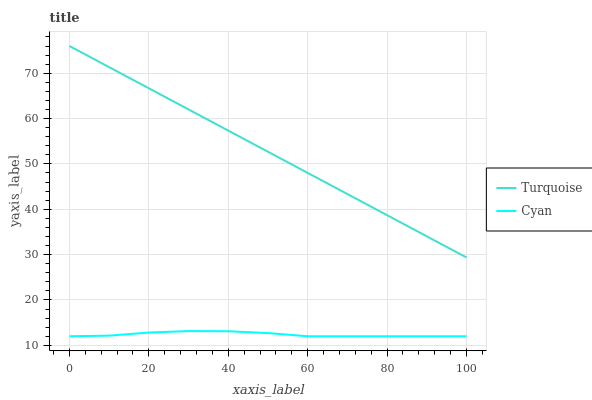Does Turquoise have the minimum area under the curve?
Answer yes or no. No. Is Turquoise the roughest?
Answer yes or no. No. Does Turquoise have the lowest value?
Answer yes or no. No. Is Cyan less than Turquoise?
Answer yes or no. Yes. Is Turquoise greater than Cyan?
Answer yes or no. Yes. Does Cyan intersect Turquoise?
Answer yes or no. No. 